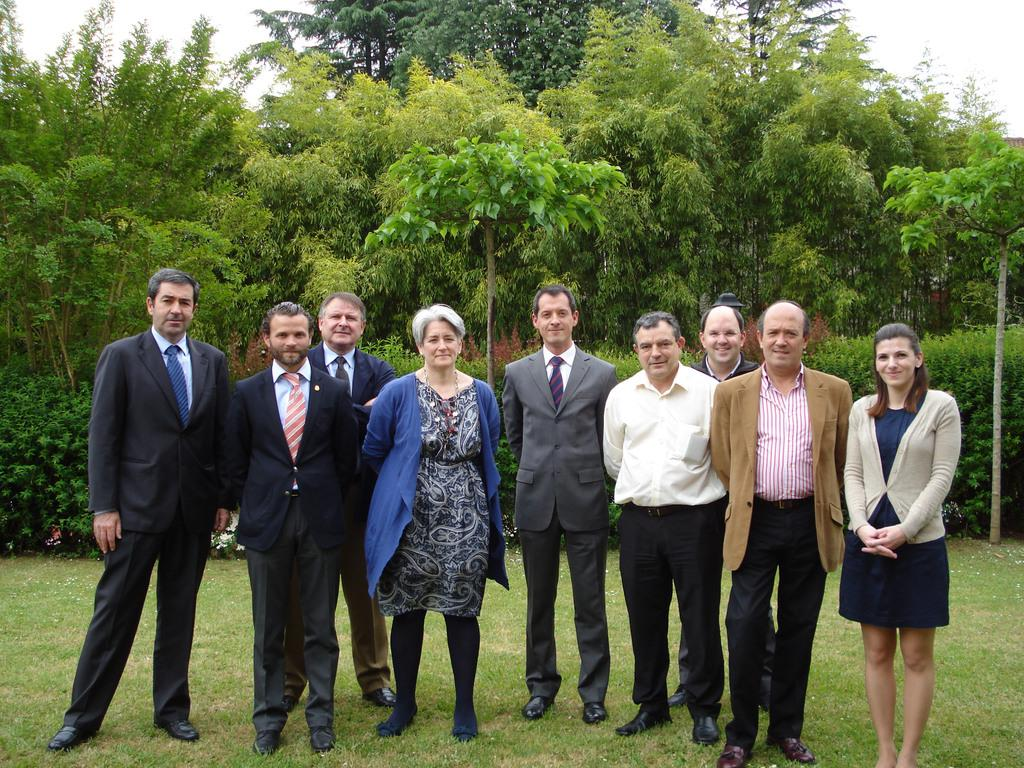What can be seen in the foreground of the picture? There are people standing in the foreground of the picture, and there is grass as well. What is visible in the background of the picture? There are trees and plants in the background of the picture. How would you describe the sky in the image? The sky is cloudy in the image. What is the process of digestion for the bear in the image? There is no bear present in the image, so we cannot discuss the process of digestion for a bear. 